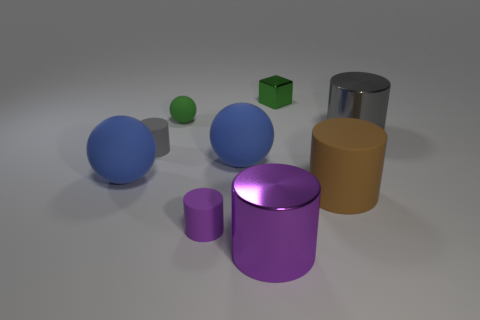Are there any patterns or textures on the objects? The objects appear to be smooth and lack any distinct patterns or textures, emphasizing their geometric purity.  Does the lighting suggest anything about the setting or mood? The soft, diffuse lighting gives the scene a calm and neutral mood, and it doesn't hint at a specific setting, suggesting a focus on the shapes themselves. 